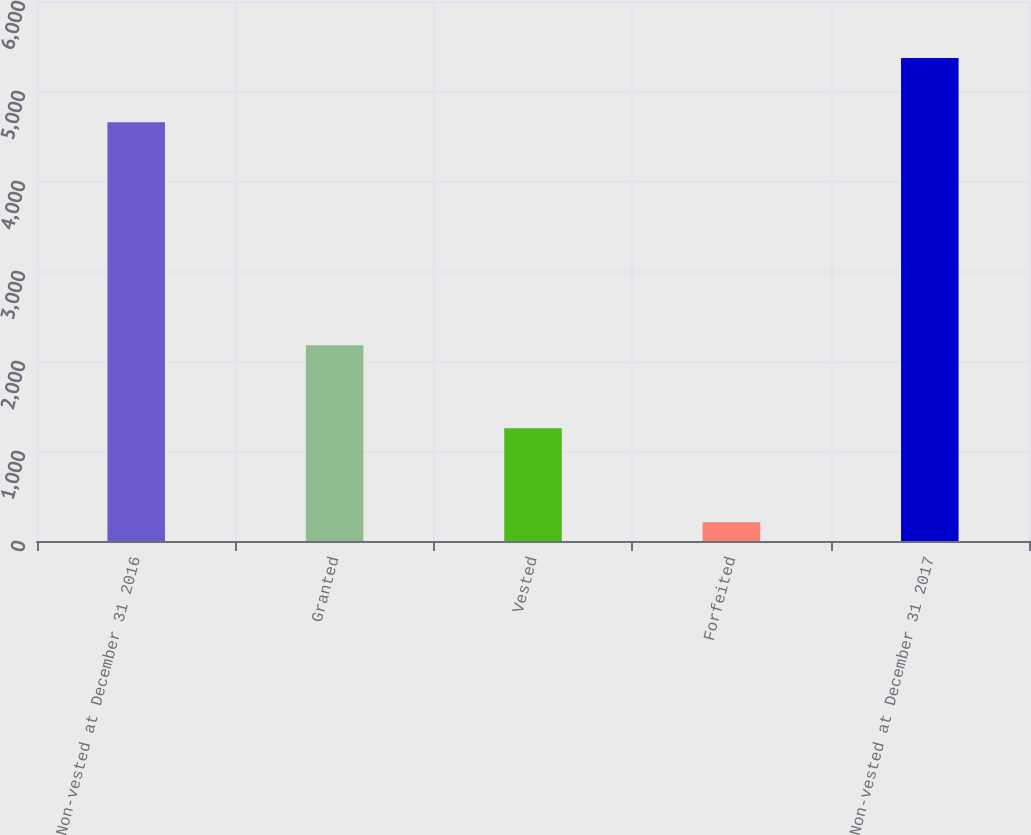<chart> <loc_0><loc_0><loc_500><loc_500><bar_chart><fcel>Non-vested at December 31 2016<fcel>Granted<fcel>Vested<fcel>Forfeited<fcel>Non-vested at December 31 2017<nl><fcel>4653<fcel>2176<fcel>1253<fcel>209<fcel>5367<nl></chart> 